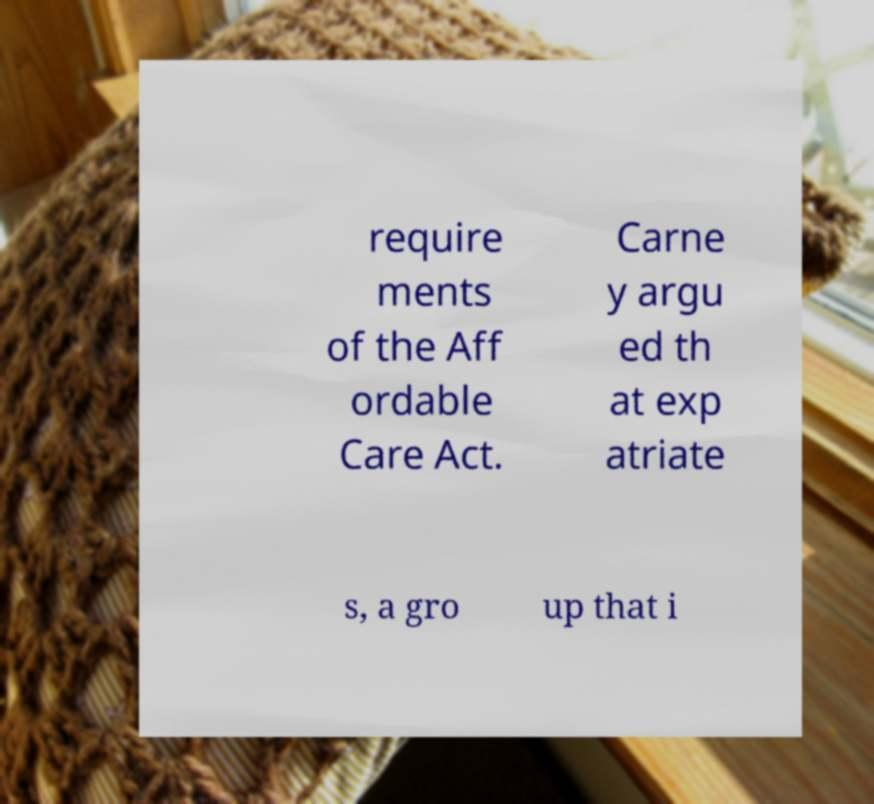Can you accurately transcribe the text from the provided image for me? require ments of the Aff ordable Care Act. Carne y argu ed th at exp atriate s, a gro up that i 